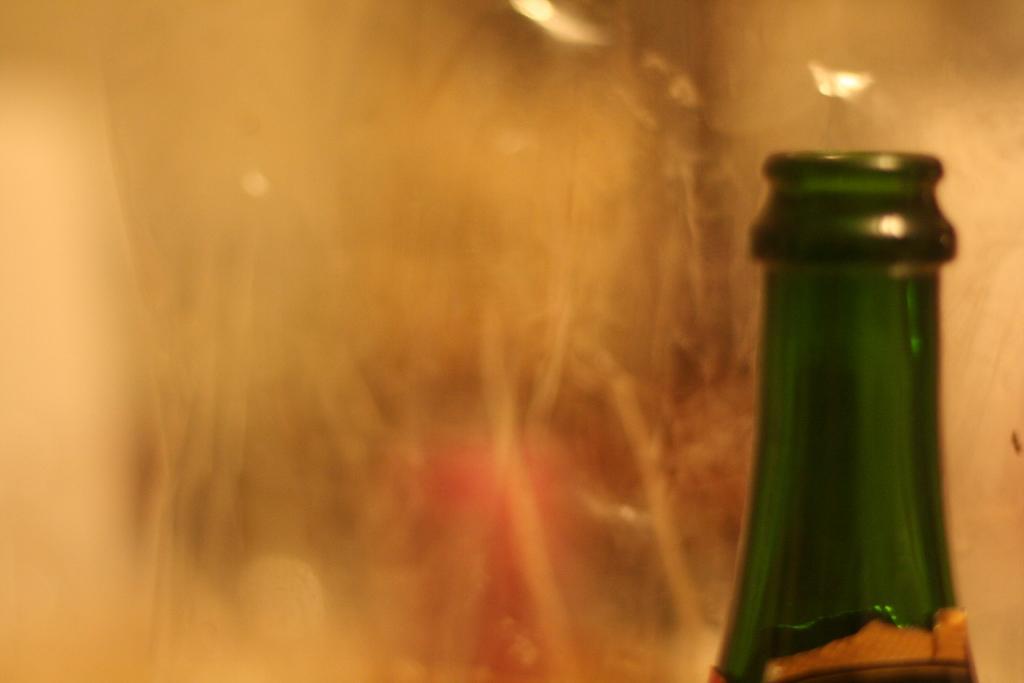Could you give a brief overview of what you see in this image? In this image we can see a bottle with blurry background. 